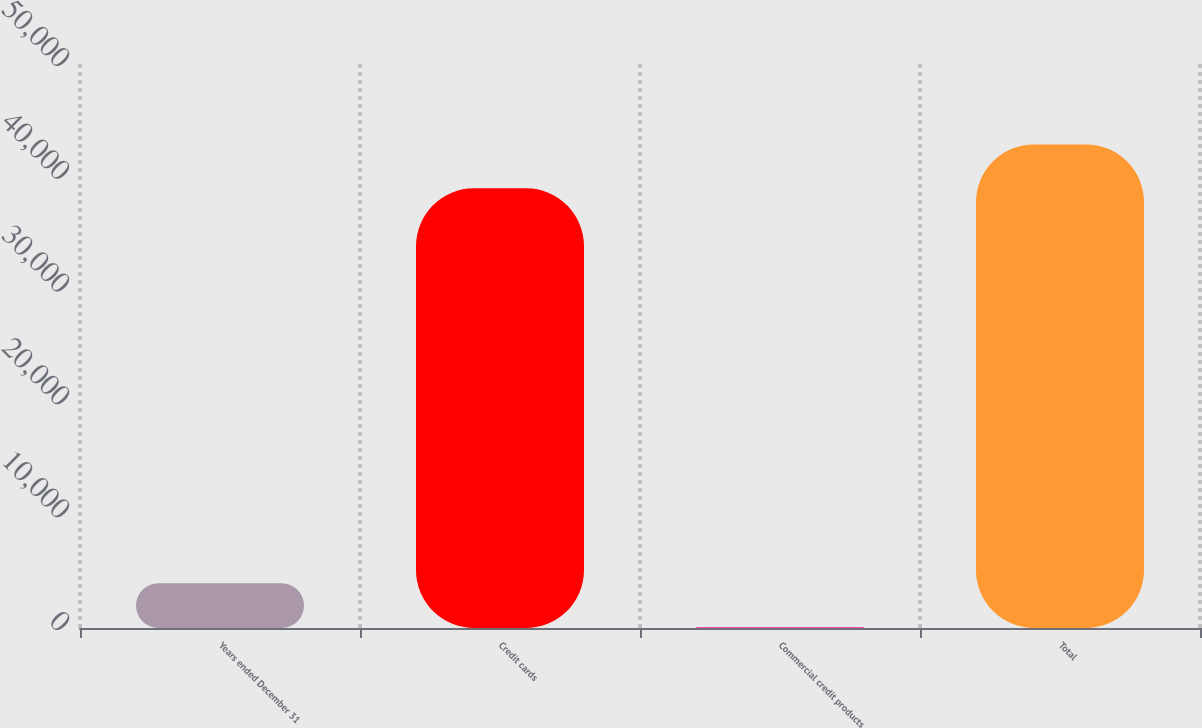Convert chart. <chart><loc_0><loc_0><loc_500><loc_500><bar_chart><fcel>Years ended December 31<fcel>Credit cards<fcel>Commercial credit products<fcel>Total<nl><fcel>3973.6<fcel>38976<fcel>76<fcel>42873.6<nl></chart> 